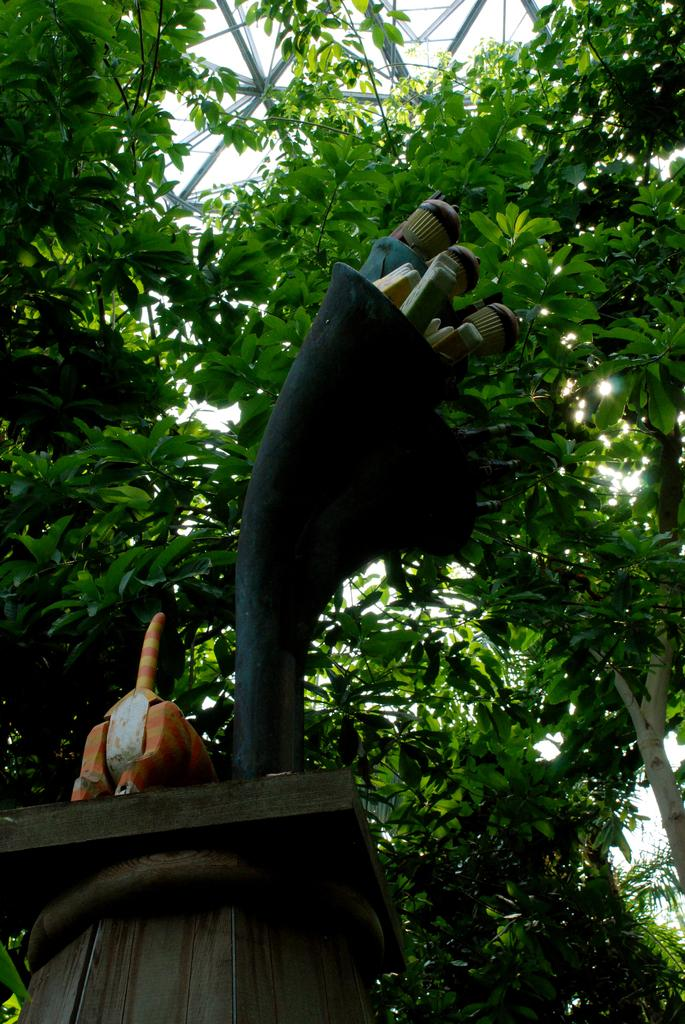What is the main subject of the image? There is a structure on a wooden stand in the image. What is placed on the wooden stand? There is an object on the stand. What can be seen in the background of the image? Trees and metal rods are present in the background of the image. What type of ink is being used by the band in the image? There is no band or ink present in the image. How many boots can be seen in the image? There are no boots present in the image. 